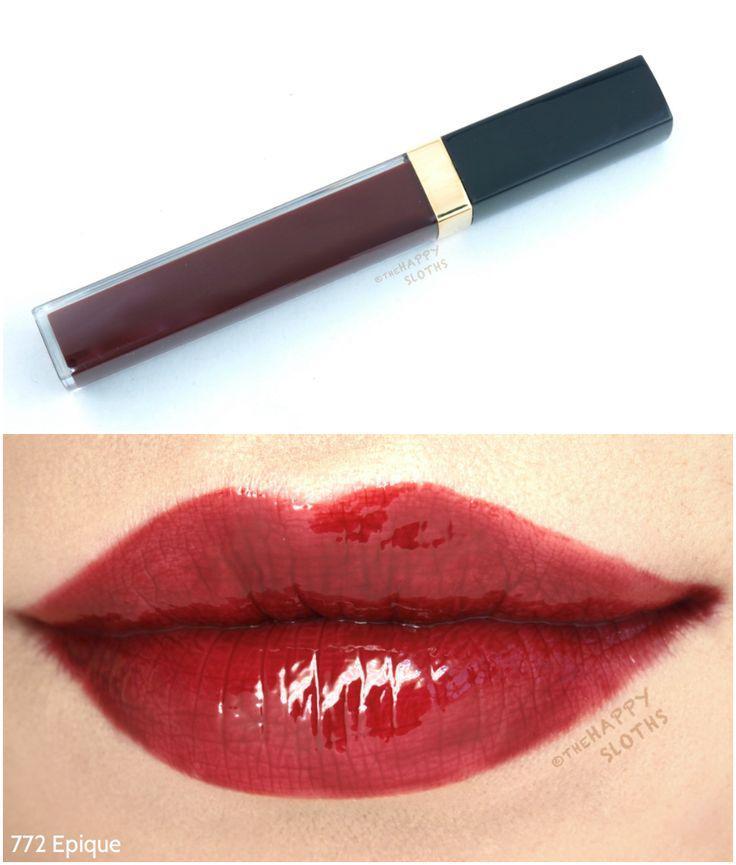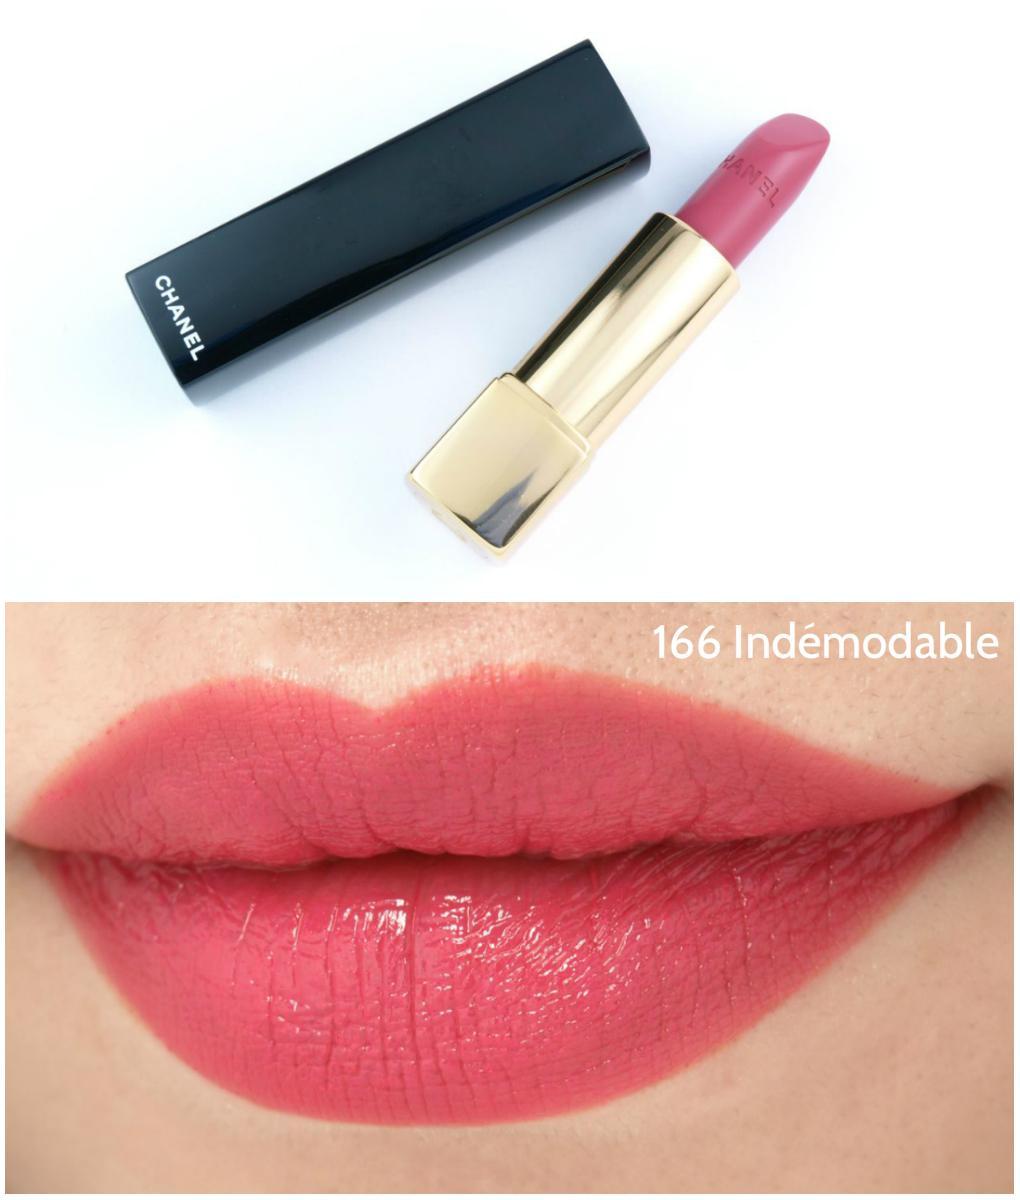The first image is the image on the left, the second image is the image on the right. For the images displayed, is the sentence "One image shows an unlidded tube lipstick next to a small pot with a solid-colored top, over a pair of tinted lips." factually correct? Answer yes or no. No. The first image is the image on the left, the second image is the image on the right. For the images shown, is this caption "The lipstick on the left comes in a red case." true? Answer yes or no. No. 